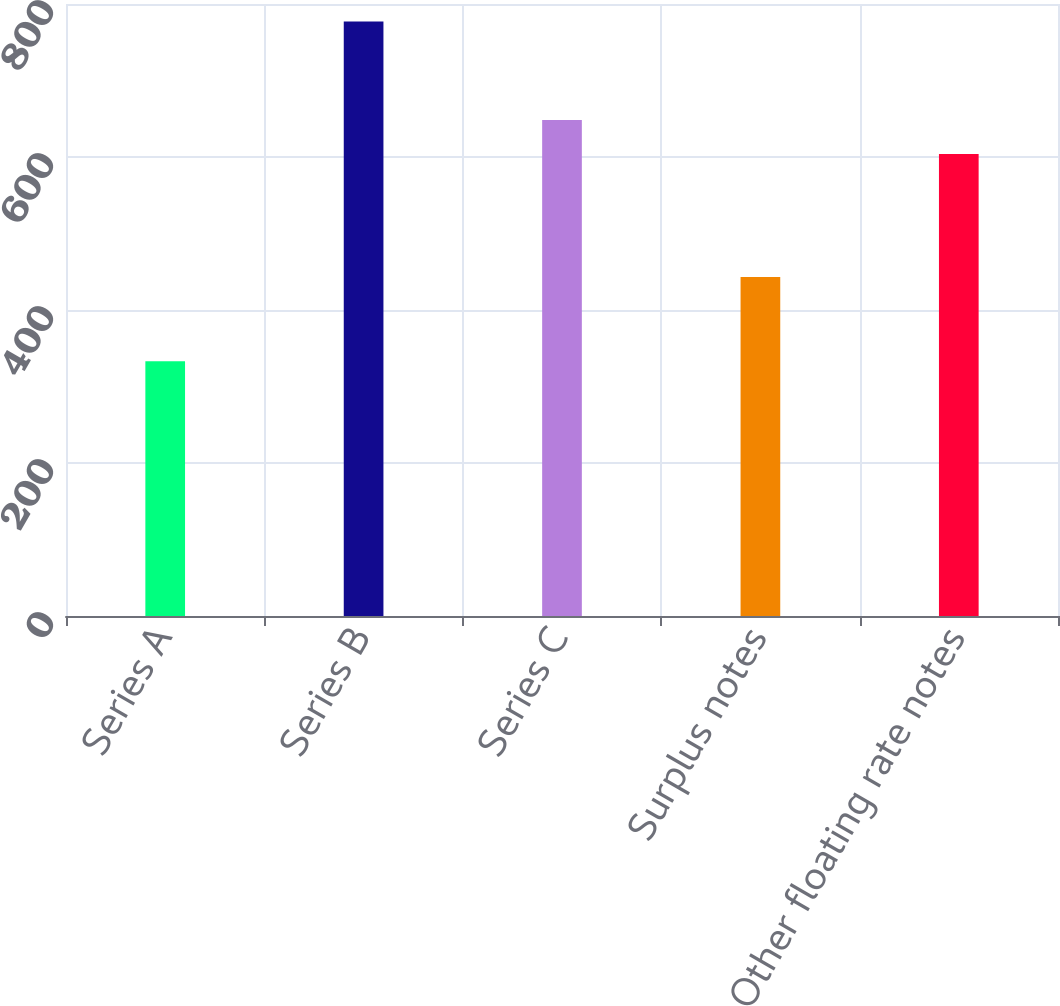Convert chart to OTSL. <chart><loc_0><loc_0><loc_500><loc_500><bar_chart><fcel>Series A<fcel>Series B<fcel>Series C<fcel>Surplus notes<fcel>Other floating rate notes<nl><fcel>333<fcel>777<fcel>648.4<fcel>443<fcel>604<nl></chart> 